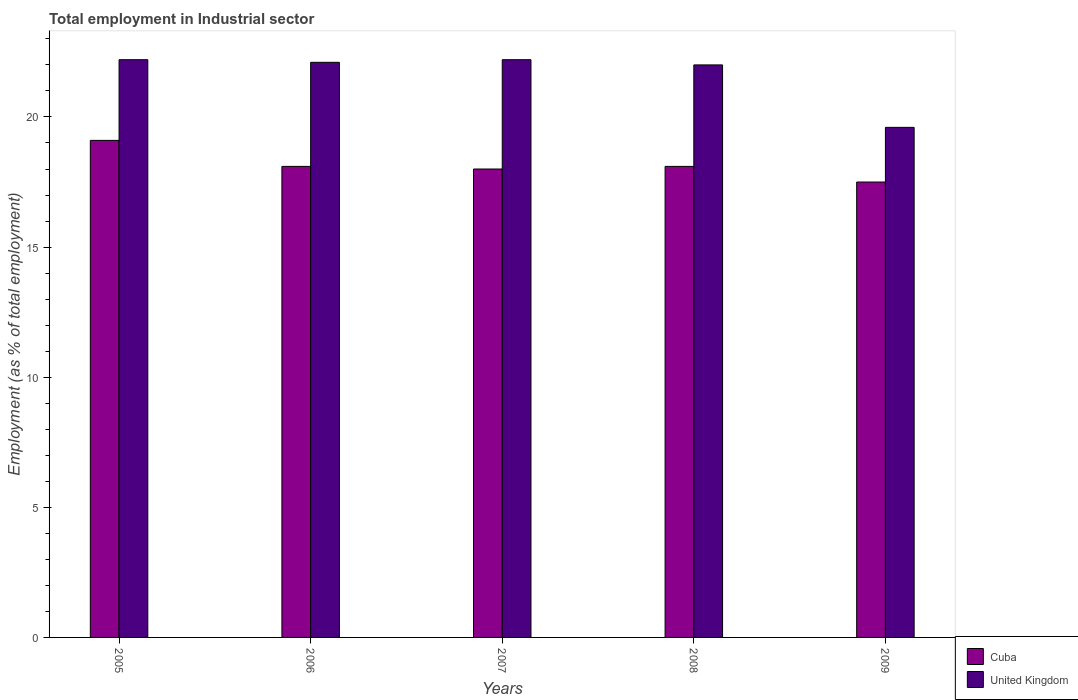How many groups of bars are there?
Your answer should be very brief. 5. Are the number of bars on each tick of the X-axis equal?
Give a very brief answer. Yes. How many bars are there on the 4th tick from the left?
Your response must be concise. 2. How many bars are there on the 5th tick from the right?
Provide a short and direct response. 2. What is the employment in industrial sector in Cuba in 2006?
Give a very brief answer. 18.1. Across all years, what is the maximum employment in industrial sector in Cuba?
Ensure brevity in your answer.  19.1. Across all years, what is the minimum employment in industrial sector in United Kingdom?
Your answer should be very brief. 19.6. In which year was the employment in industrial sector in Cuba maximum?
Your answer should be very brief. 2005. What is the total employment in industrial sector in Cuba in the graph?
Make the answer very short. 90.8. What is the difference between the employment in industrial sector in United Kingdom in 2007 and that in 2008?
Keep it short and to the point. 0.2. What is the average employment in industrial sector in Cuba per year?
Ensure brevity in your answer.  18.16. In the year 2008, what is the difference between the employment in industrial sector in Cuba and employment in industrial sector in United Kingdom?
Make the answer very short. -3.9. What is the ratio of the employment in industrial sector in United Kingdom in 2005 to that in 2009?
Your answer should be very brief. 1.13. Is the employment in industrial sector in Cuba in 2008 less than that in 2009?
Give a very brief answer. No. Is the difference between the employment in industrial sector in Cuba in 2007 and 2008 greater than the difference between the employment in industrial sector in United Kingdom in 2007 and 2008?
Keep it short and to the point. No. What is the difference between the highest and the lowest employment in industrial sector in United Kingdom?
Offer a very short reply. 2.6. What does the 2nd bar from the left in 2009 represents?
Make the answer very short. United Kingdom. What does the 2nd bar from the right in 2006 represents?
Offer a very short reply. Cuba. How many bars are there?
Offer a terse response. 10. How many years are there in the graph?
Provide a succinct answer. 5. What is the difference between two consecutive major ticks on the Y-axis?
Provide a succinct answer. 5. Does the graph contain any zero values?
Your response must be concise. No. Where does the legend appear in the graph?
Offer a terse response. Bottom right. How many legend labels are there?
Your response must be concise. 2. What is the title of the graph?
Provide a succinct answer. Total employment in Industrial sector. What is the label or title of the X-axis?
Give a very brief answer. Years. What is the label or title of the Y-axis?
Provide a succinct answer. Employment (as % of total employment). What is the Employment (as % of total employment) of Cuba in 2005?
Your response must be concise. 19.1. What is the Employment (as % of total employment) in United Kingdom in 2005?
Give a very brief answer. 22.2. What is the Employment (as % of total employment) in Cuba in 2006?
Your answer should be very brief. 18.1. What is the Employment (as % of total employment) in United Kingdom in 2006?
Provide a short and direct response. 22.1. What is the Employment (as % of total employment) of United Kingdom in 2007?
Ensure brevity in your answer.  22.2. What is the Employment (as % of total employment) in Cuba in 2008?
Offer a very short reply. 18.1. What is the Employment (as % of total employment) of United Kingdom in 2008?
Your response must be concise. 22. What is the Employment (as % of total employment) in United Kingdom in 2009?
Offer a very short reply. 19.6. Across all years, what is the maximum Employment (as % of total employment) of Cuba?
Your answer should be compact. 19.1. Across all years, what is the maximum Employment (as % of total employment) in United Kingdom?
Your response must be concise. 22.2. Across all years, what is the minimum Employment (as % of total employment) in United Kingdom?
Your answer should be compact. 19.6. What is the total Employment (as % of total employment) in Cuba in the graph?
Your response must be concise. 90.8. What is the total Employment (as % of total employment) in United Kingdom in the graph?
Provide a short and direct response. 108.1. What is the difference between the Employment (as % of total employment) of Cuba in 2005 and that in 2006?
Your response must be concise. 1. What is the difference between the Employment (as % of total employment) of United Kingdom in 2005 and that in 2006?
Provide a short and direct response. 0.1. What is the difference between the Employment (as % of total employment) of Cuba in 2005 and that in 2007?
Ensure brevity in your answer.  1.1. What is the difference between the Employment (as % of total employment) of United Kingdom in 2005 and that in 2007?
Offer a terse response. 0. What is the difference between the Employment (as % of total employment) of United Kingdom in 2005 and that in 2008?
Provide a succinct answer. 0.2. What is the difference between the Employment (as % of total employment) of Cuba in 2006 and that in 2007?
Ensure brevity in your answer.  0.1. What is the difference between the Employment (as % of total employment) of United Kingdom in 2006 and that in 2007?
Your answer should be compact. -0.1. What is the difference between the Employment (as % of total employment) of Cuba in 2006 and that in 2008?
Keep it short and to the point. 0. What is the difference between the Employment (as % of total employment) of United Kingdom in 2006 and that in 2009?
Provide a short and direct response. 2.5. What is the difference between the Employment (as % of total employment) of United Kingdom in 2007 and that in 2008?
Offer a terse response. 0.2. What is the difference between the Employment (as % of total employment) in Cuba in 2008 and that in 2009?
Keep it short and to the point. 0.6. What is the difference between the Employment (as % of total employment) in United Kingdom in 2008 and that in 2009?
Give a very brief answer. 2.4. What is the difference between the Employment (as % of total employment) in Cuba in 2005 and the Employment (as % of total employment) in United Kingdom in 2006?
Provide a short and direct response. -3. What is the difference between the Employment (as % of total employment) of Cuba in 2005 and the Employment (as % of total employment) of United Kingdom in 2009?
Offer a terse response. -0.5. What is the difference between the Employment (as % of total employment) of Cuba in 2006 and the Employment (as % of total employment) of United Kingdom in 2008?
Provide a succinct answer. -3.9. What is the difference between the Employment (as % of total employment) of Cuba in 2006 and the Employment (as % of total employment) of United Kingdom in 2009?
Keep it short and to the point. -1.5. What is the difference between the Employment (as % of total employment) of Cuba in 2007 and the Employment (as % of total employment) of United Kingdom in 2008?
Your answer should be compact. -4. What is the average Employment (as % of total employment) of Cuba per year?
Provide a short and direct response. 18.16. What is the average Employment (as % of total employment) of United Kingdom per year?
Offer a very short reply. 21.62. In the year 2007, what is the difference between the Employment (as % of total employment) of Cuba and Employment (as % of total employment) of United Kingdom?
Provide a succinct answer. -4.2. In the year 2008, what is the difference between the Employment (as % of total employment) of Cuba and Employment (as % of total employment) of United Kingdom?
Make the answer very short. -3.9. What is the ratio of the Employment (as % of total employment) in Cuba in 2005 to that in 2006?
Offer a very short reply. 1.06. What is the ratio of the Employment (as % of total employment) in Cuba in 2005 to that in 2007?
Offer a very short reply. 1.06. What is the ratio of the Employment (as % of total employment) of United Kingdom in 2005 to that in 2007?
Offer a very short reply. 1. What is the ratio of the Employment (as % of total employment) of Cuba in 2005 to that in 2008?
Your response must be concise. 1.06. What is the ratio of the Employment (as % of total employment) in United Kingdom in 2005 to that in 2008?
Give a very brief answer. 1.01. What is the ratio of the Employment (as % of total employment) in Cuba in 2005 to that in 2009?
Offer a very short reply. 1.09. What is the ratio of the Employment (as % of total employment) of United Kingdom in 2005 to that in 2009?
Provide a short and direct response. 1.13. What is the ratio of the Employment (as % of total employment) of Cuba in 2006 to that in 2007?
Provide a short and direct response. 1.01. What is the ratio of the Employment (as % of total employment) in United Kingdom in 2006 to that in 2007?
Provide a short and direct response. 1. What is the ratio of the Employment (as % of total employment) of Cuba in 2006 to that in 2008?
Ensure brevity in your answer.  1. What is the ratio of the Employment (as % of total employment) of United Kingdom in 2006 to that in 2008?
Your response must be concise. 1. What is the ratio of the Employment (as % of total employment) of Cuba in 2006 to that in 2009?
Your answer should be very brief. 1.03. What is the ratio of the Employment (as % of total employment) of United Kingdom in 2006 to that in 2009?
Make the answer very short. 1.13. What is the ratio of the Employment (as % of total employment) in United Kingdom in 2007 to that in 2008?
Make the answer very short. 1.01. What is the ratio of the Employment (as % of total employment) in Cuba in 2007 to that in 2009?
Your answer should be compact. 1.03. What is the ratio of the Employment (as % of total employment) of United Kingdom in 2007 to that in 2009?
Keep it short and to the point. 1.13. What is the ratio of the Employment (as % of total employment) in Cuba in 2008 to that in 2009?
Your response must be concise. 1.03. What is the ratio of the Employment (as % of total employment) in United Kingdom in 2008 to that in 2009?
Make the answer very short. 1.12. 